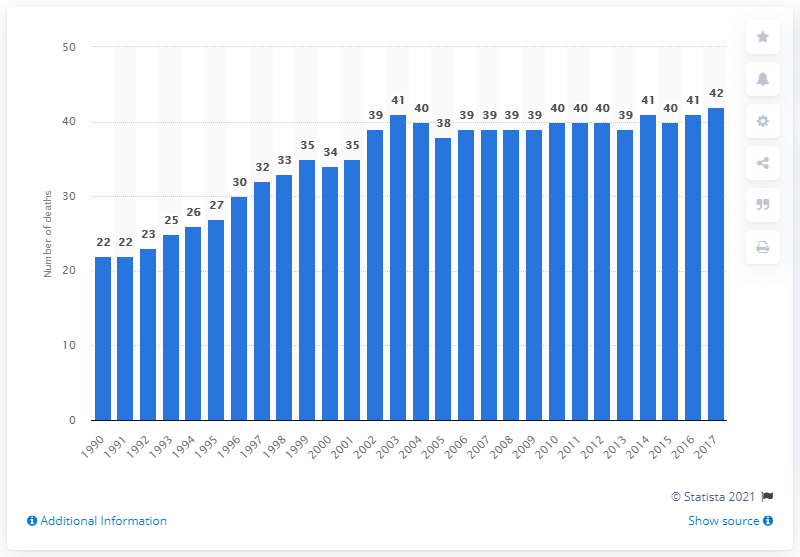Outline some significant characteristics in this image. In 1990, an estimated 22 people died as a result of eating disorders each year. 